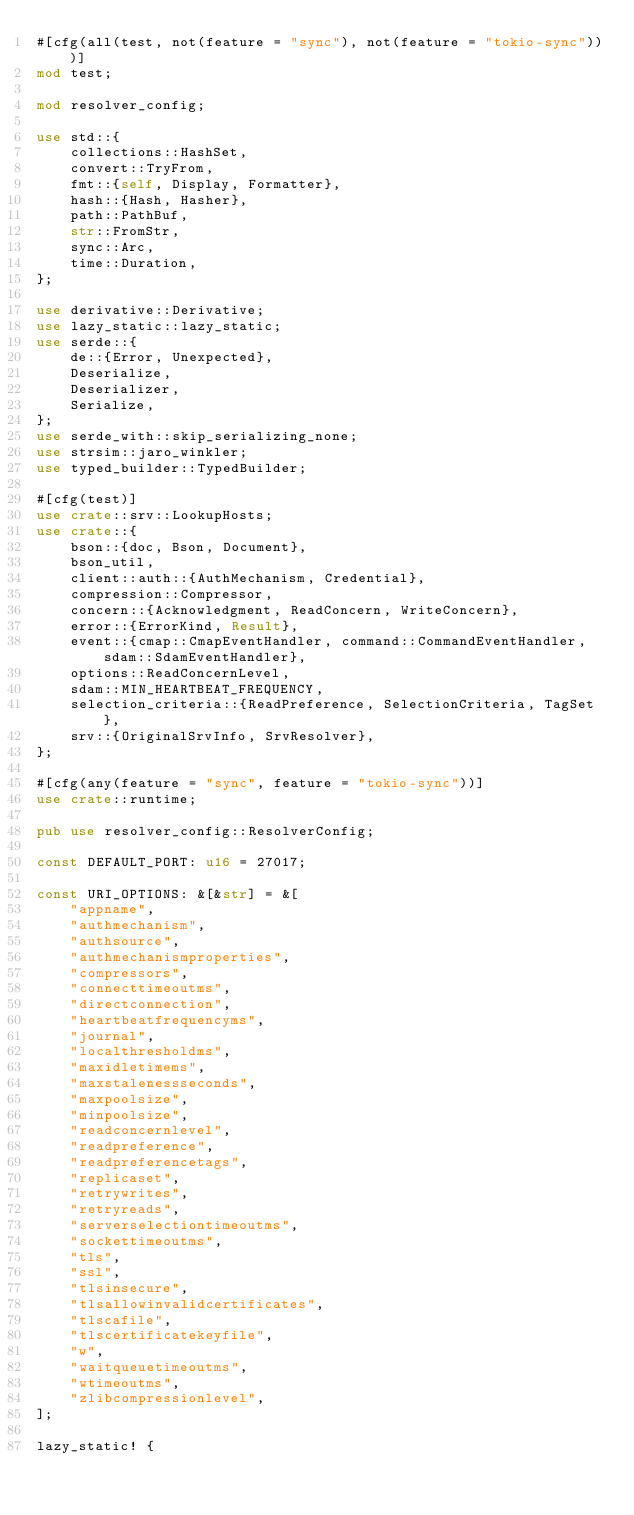<code> <loc_0><loc_0><loc_500><loc_500><_Rust_>#[cfg(all(test, not(feature = "sync"), not(feature = "tokio-sync")))]
mod test;

mod resolver_config;

use std::{
    collections::HashSet,
    convert::TryFrom,
    fmt::{self, Display, Formatter},
    hash::{Hash, Hasher},
    path::PathBuf,
    str::FromStr,
    sync::Arc,
    time::Duration,
};

use derivative::Derivative;
use lazy_static::lazy_static;
use serde::{
    de::{Error, Unexpected},
    Deserialize,
    Deserializer,
    Serialize,
};
use serde_with::skip_serializing_none;
use strsim::jaro_winkler;
use typed_builder::TypedBuilder;

#[cfg(test)]
use crate::srv::LookupHosts;
use crate::{
    bson::{doc, Bson, Document},
    bson_util,
    client::auth::{AuthMechanism, Credential},
    compression::Compressor,
    concern::{Acknowledgment, ReadConcern, WriteConcern},
    error::{ErrorKind, Result},
    event::{cmap::CmapEventHandler, command::CommandEventHandler, sdam::SdamEventHandler},
    options::ReadConcernLevel,
    sdam::MIN_HEARTBEAT_FREQUENCY,
    selection_criteria::{ReadPreference, SelectionCriteria, TagSet},
    srv::{OriginalSrvInfo, SrvResolver},
};

#[cfg(any(feature = "sync", feature = "tokio-sync"))]
use crate::runtime;

pub use resolver_config::ResolverConfig;

const DEFAULT_PORT: u16 = 27017;

const URI_OPTIONS: &[&str] = &[
    "appname",
    "authmechanism",
    "authsource",
    "authmechanismproperties",
    "compressors",
    "connecttimeoutms",
    "directconnection",
    "heartbeatfrequencyms",
    "journal",
    "localthresholdms",
    "maxidletimems",
    "maxstalenessseconds",
    "maxpoolsize",
    "minpoolsize",
    "readconcernlevel",
    "readpreference",
    "readpreferencetags",
    "replicaset",
    "retrywrites",
    "retryreads",
    "serverselectiontimeoutms",
    "sockettimeoutms",
    "tls",
    "ssl",
    "tlsinsecure",
    "tlsallowinvalidcertificates",
    "tlscafile",
    "tlscertificatekeyfile",
    "w",
    "waitqueuetimeoutms",
    "wtimeoutms",
    "zlibcompressionlevel",
];

lazy_static! {</code> 